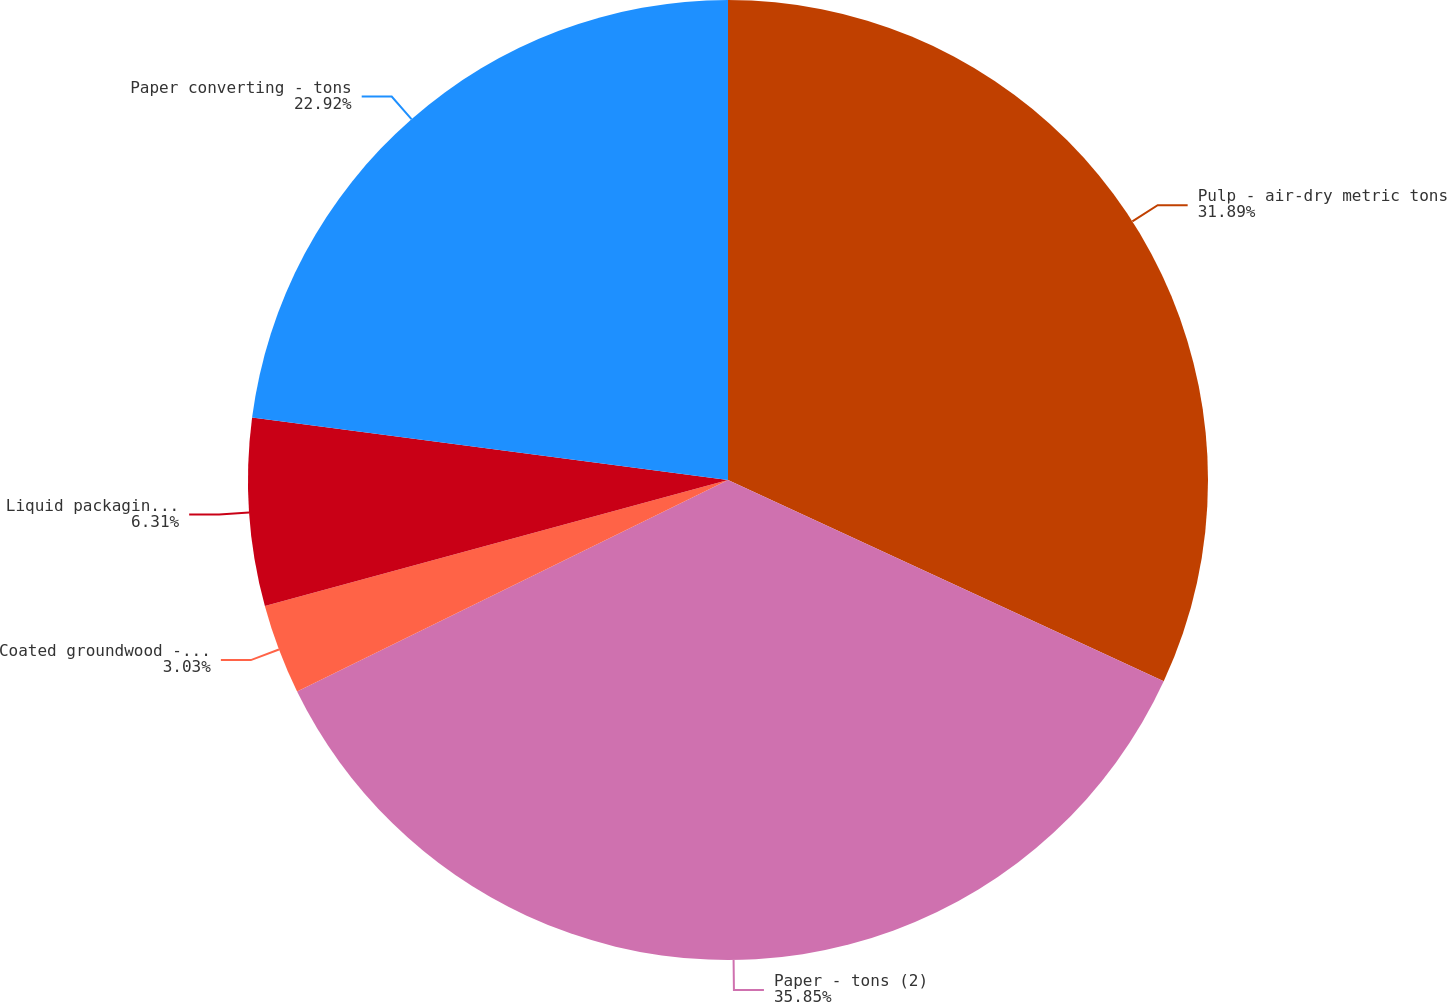Convert chart to OTSL. <chart><loc_0><loc_0><loc_500><loc_500><pie_chart><fcel>Pulp - air-dry metric tons<fcel>Paper - tons (2)<fcel>Coated groundwood - tons<fcel>Liquid packaging board - tons<fcel>Paper converting - tons<nl><fcel>31.89%<fcel>35.85%<fcel>3.03%<fcel>6.31%<fcel>22.92%<nl></chart> 